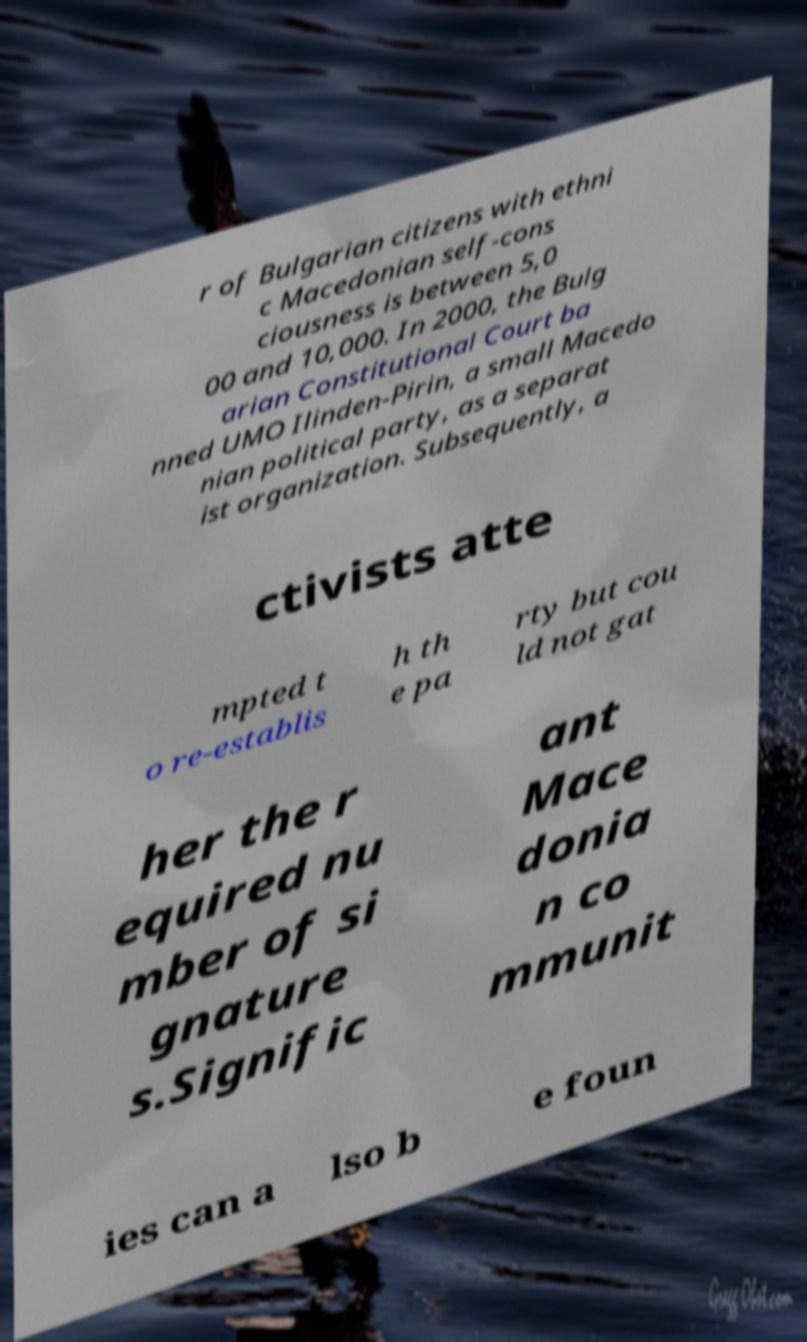Could you assist in decoding the text presented in this image and type it out clearly? r of Bulgarian citizens with ethni c Macedonian self-cons ciousness is between 5,0 00 and 10,000. In 2000, the Bulg arian Constitutional Court ba nned UMO Ilinden-Pirin, a small Macedo nian political party, as a separat ist organization. Subsequently, a ctivists atte mpted t o re-establis h th e pa rty but cou ld not gat her the r equired nu mber of si gnature s.Signific ant Mace donia n co mmunit ies can a lso b e foun 